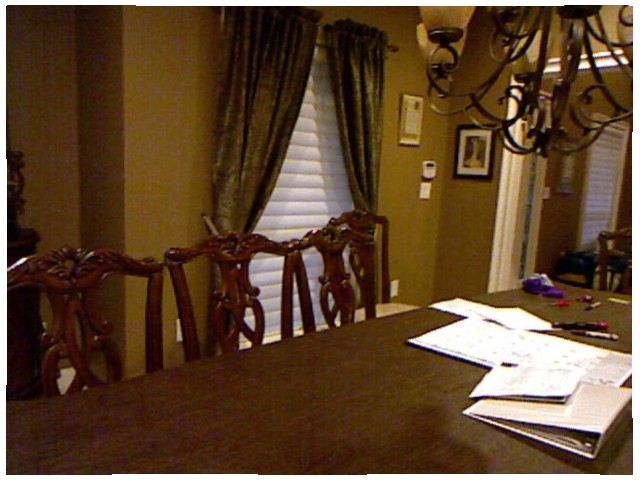<image>
Is there a calendar on the table? Yes. Looking at the image, I can see the calendar is positioned on top of the table, with the table providing support. Is there a chair on the table? No. The chair is not positioned on the table. They may be near each other, but the chair is not supported by or resting on top of the table. Where is the chair in relation to the table? Is it to the left of the table? Yes. From this viewpoint, the chair is positioned to the left side relative to the table. Is there a table behind the chair? Yes. From this viewpoint, the table is positioned behind the chair, with the chair partially or fully occluding the table. 